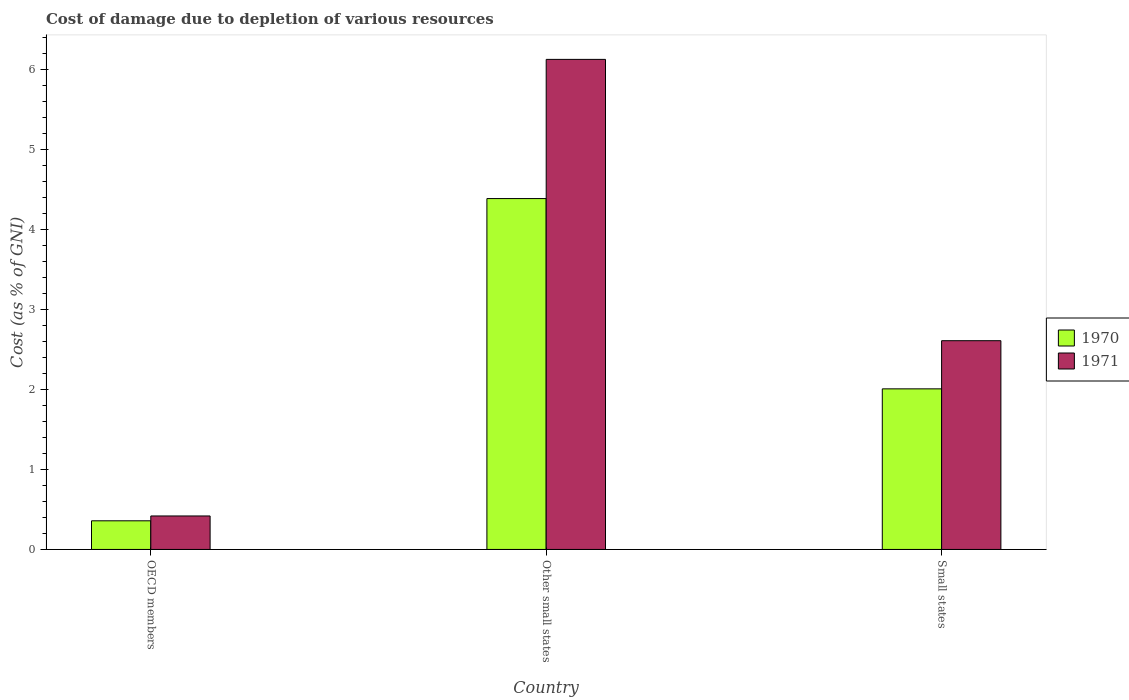Are the number of bars on each tick of the X-axis equal?
Ensure brevity in your answer.  Yes. What is the label of the 3rd group of bars from the left?
Ensure brevity in your answer.  Small states. In how many cases, is the number of bars for a given country not equal to the number of legend labels?
Offer a very short reply. 0. What is the cost of damage caused due to the depletion of various resources in 1970 in Other small states?
Provide a short and direct response. 4.39. Across all countries, what is the maximum cost of damage caused due to the depletion of various resources in 1970?
Your answer should be very brief. 4.39. Across all countries, what is the minimum cost of damage caused due to the depletion of various resources in 1971?
Offer a terse response. 0.42. In which country was the cost of damage caused due to the depletion of various resources in 1970 maximum?
Keep it short and to the point. Other small states. In which country was the cost of damage caused due to the depletion of various resources in 1970 minimum?
Your response must be concise. OECD members. What is the total cost of damage caused due to the depletion of various resources in 1971 in the graph?
Offer a very short reply. 9.15. What is the difference between the cost of damage caused due to the depletion of various resources in 1970 in Other small states and that in Small states?
Your response must be concise. 2.38. What is the difference between the cost of damage caused due to the depletion of various resources in 1970 in Other small states and the cost of damage caused due to the depletion of various resources in 1971 in Small states?
Your answer should be compact. 1.78. What is the average cost of damage caused due to the depletion of various resources in 1971 per country?
Offer a very short reply. 3.05. What is the difference between the cost of damage caused due to the depletion of various resources of/in 1971 and cost of damage caused due to the depletion of various resources of/in 1970 in OECD members?
Your response must be concise. 0.06. In how many countries, is the cost of damage caused due to the depletion of various resources in 1970 greater than 5.4 %?
Ensure brevity in your answer.  0. What is the ratio of the cost of damage caused due to the depletion of various resources in 1970 in Other small states to that in Small states?
Offer a very short reply. 2.18. Is the cost of damage caused due to the depletion of various resources in 1971 in Other small states less than that in Small states?
Your answer should be compact. No. Is the difference between the cost of damage caused due to the depletion of various resources in 1971 in OECD members and Other small states greater than the difference between the cost of damage caused due to the depletion of various resources in 1970 in OECD members and Other small states?
Offer a terse response. No. What is the difference between the highest and the second highest cost of damage caused due to the depletion of various resources in 1970?
Your answer should be very brief. -1.65. What is the difference between the highest and the lowest cost of damage caused due to the depletion of various resources in 1971?
Keep it short and to the point. 5.71. In how many countries, is the cost of damage caused due to the depletion of various resources in 1971 greater than the average cost of damage caused due to the depletion of various resources in 1971 taken over all countries?
Your answer should be very brief. 1. Is the sum of the cost of damage caused due to the depletion of various resources in 1971 in OECD members and Small states greater than the maximum cost of damage caused due to the depletion of various resources in 1970 across all countries?
Ensure brevity in your answer.  No. What is the difference between two consecutive major ticks on the Y-axis?
Give a very brief answer. 1. Does the graph contain grids?
Make the answer very short. No. How many legend labels are there?
Provide a succinct answer. 2. How are the legend labels stacked?
Offer a terse response. Vertical. What is the title of the graph?
Provide a short and direct response. Cost of damage due to depletion of various resources. Does "2007" appear as one of the legend labels in the graph?
Your response must be concise. No. What is the label or title of the Y-axis?
Your answer should be very brief. Cost (as % of GNI). What is the Cost (as % of GNI) of 1970 in OECD members?
Make the answer very short. 0.36. What is the Cost (as % of GNI) of 1971 in OECD members?
Give a very brief answer. 0.42. What is the Cost (as % of GNI) in 1970 in Other small states?
Make the answer very short. 4.39. What is the Cost (as % of GNI) in 1971 in Other small states?
Keep it short and to the point. 6.13. What is the Cost (as % of GNI) in 1970 in Small states?
Ensure brevity in your answer.  2.01. What is the Cost (as % of GNI) in 1971 in Small states?
Your answer should be compact. 2.61. Across all countries, what is the maximum Cost (as % of GNI) of 1970?
Give a very brief answer. 4.39. Across all countries, what is the maximum Cost (as % of GNI) in 1971?
Your answer should be compact. 6.13. Across all countries, what is the minimum Cost (as % of GNI) in 1970?
Ensure brevity in your answer.  0.36. Across all countries, what is the minimum Cost (as % of GNI) in 1971?
Your answer should be very brief. 0.42. What is the total Cost (as % of GNI) in 1970 in the graph?
Offer a very short reply. 6.75. What is the total Cost (as % of GNI) of 1971 in the graph?
Provide a succinct answer. 9.15. What is the difference between the Cost (as % of GNI) of 1970 in OECD members and that in Other small states?
Your answer should be compact. -4.03. What is the difference between the Cost (as % of GNI) of 1971 in OECD members and that in Other small states?
Make the answer very short. -5.71. What is the difference between the Cost (as % of GNI) in 1970 in OECD members and that in Small states?
Ensure brevity in your answer.  -1.65. What is the difference between the Cost (as % of GNI) in 1971 in OECD members and that in Small states?
Give a very brief answer. -2.19. What is the difference between the Cost (as % of GNI) in 1970 in Other small states and that in Small states?
Ensure brevity in your answer.  2.38. What is the difference between the Cost (as % of GNI) in 1971 in Other small states and that in Small states?
Your response must be concise. 3.52. What is the difference between the Cost (as % of GNI) of 1970 in OECD members and the Cost (as % of GNI) of 1971 in Other small states?
Make the answer very short. -5.77. What is the difference between the Cost (as % of GNI) in 1970 in OECD members and the Cost (as % of GNI) in 1971 in Small states?
Your answer should be compact. -2.25. What is the difference between the Cost (as % of GNI) in 1970 in Other small states and the Cost (as % of GNI) in 1971 in Small states?
Offer a very short reply. 1.78. What is the average Cost (as % of GNI) in 1970 per country?
Make the answer very short. 2.25. What is the average Cost (as % of GNI) in 1971 per country?
Offer a very short reply. 3.05. What is the difference between the Cost (as % of GNI) in 1970 and Cost (as % of GNI) in 1971 in OECD members?
Provide a short and direct response. -0.06. What is the difference between the Cost (as % of GNI) of 1970 and Cost (as % of GNI) of 1971 in Other small states?
Offer a terse response. -1.74. What is the difference between the Cost (as % of GNI) of 1970 and Cost (as % of GNI) of 1971 in Small states?
Provide a succinct answer. -0.6. What is the ratio of the Cost (as % of GNI) of 1970 in OECD members to that in Other small states?
Ensure brevity in your answer.  0.08. What is the ratio of the Cost (as % of GNI) in 1971 in OECD members to that in Other small states?
Your answer should be very brief. 0.07. What is the ratio of the Cost (as % of GNI) of 1970 in OECD members to that in Small states?
Provide a short and direct response. 0.18. What is the ratio of the Cost (as % of GNI) of 1971 in OECD members to that in Small states?
Offer a very short reply. 0.16. What is the ratio of the Cost (as % of GNI) in 1970 in Other small states to that in Small states?
Your answer should be very brief. 2.18. What is the ratio of the Cost (as % of GNI) of 1971 in Other small states to that in Small states?
Your answer should be compact. 2.35. What is the difference between the highest and the second highest Cost (as % of GNI) in 1970?
Make the answer very short. 2.38. What is the difference between the highest and the second highest Cost (as % of GNI) in 1971?
Keep it short and to the point. 3.52. What is the difference between the highest and the lowest Cost (as % of GNI) of 1970?
Ensure brevity in your answer.  4.03. What is the difference between the highest and the lowest Cost (as % of GNI) in 1971?
Offer a terse response. 5.71. 